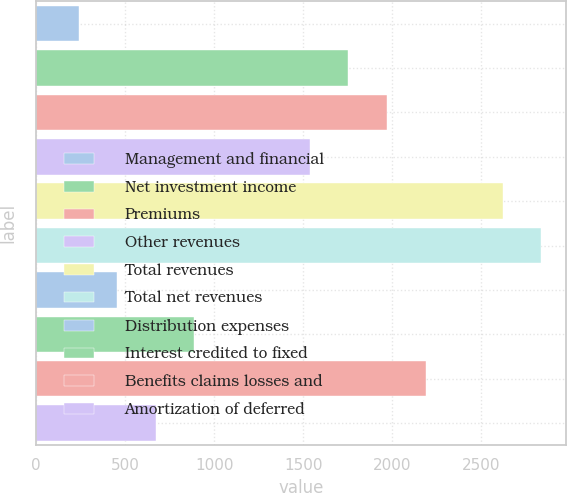<chart> <loc_0><loc_0><loc_500><loc_500><bar_chart><fcel>Management and financial<fcel>Net investment income<fcel>Premiums<fcel>Other revenues<fcel>Total revenues<fcel>Total net revenues<fcel>Distribution expenses<fcel>Interest credited to fixed<fcel>Benefits claims losses and<fcel>Amortization of deferred<nl><fcel>241.1<fcel>1753.8<fcel>1969.9<fcel>1537.7<fcel>2618.2<fcel>2834.3<fcel>457.2<fcel>889.4<fcel>2186<fcel>673.3<nl></chart> 